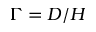Convert formula to latex. <formula><loc_0><loc_0><loc_500><loc_500>\Gamma = D / H</formula> 